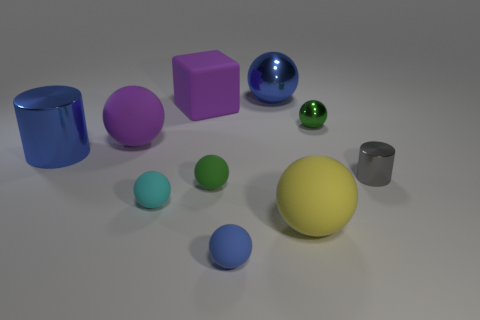Are any small blue rubber spheres visible? yes 